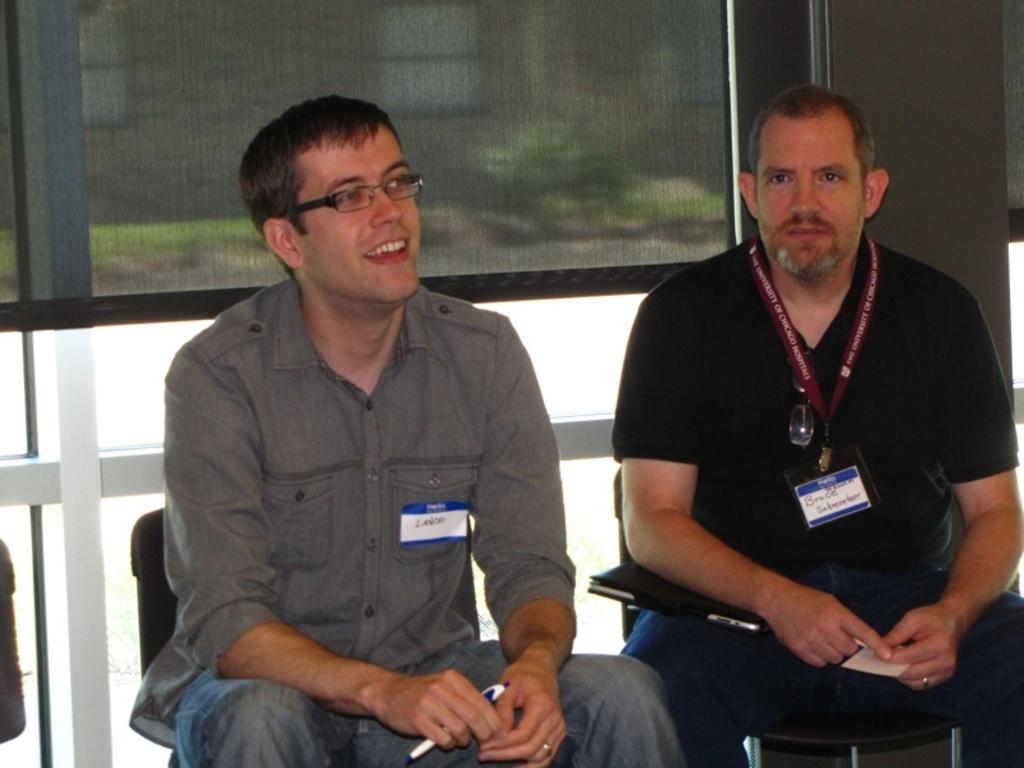How many people are in the image? There are two men in the image. What are the men doing in the image? The men are sitting on chairs and smiling. What can be seen in the background of the image? There is a window and a wall visible in the image. What items are present on the men or around them? There are badges and an electronic gadget in the image. Can you see any horses or lettuce in the image? No, there are no horses or lettuce present in the image. 